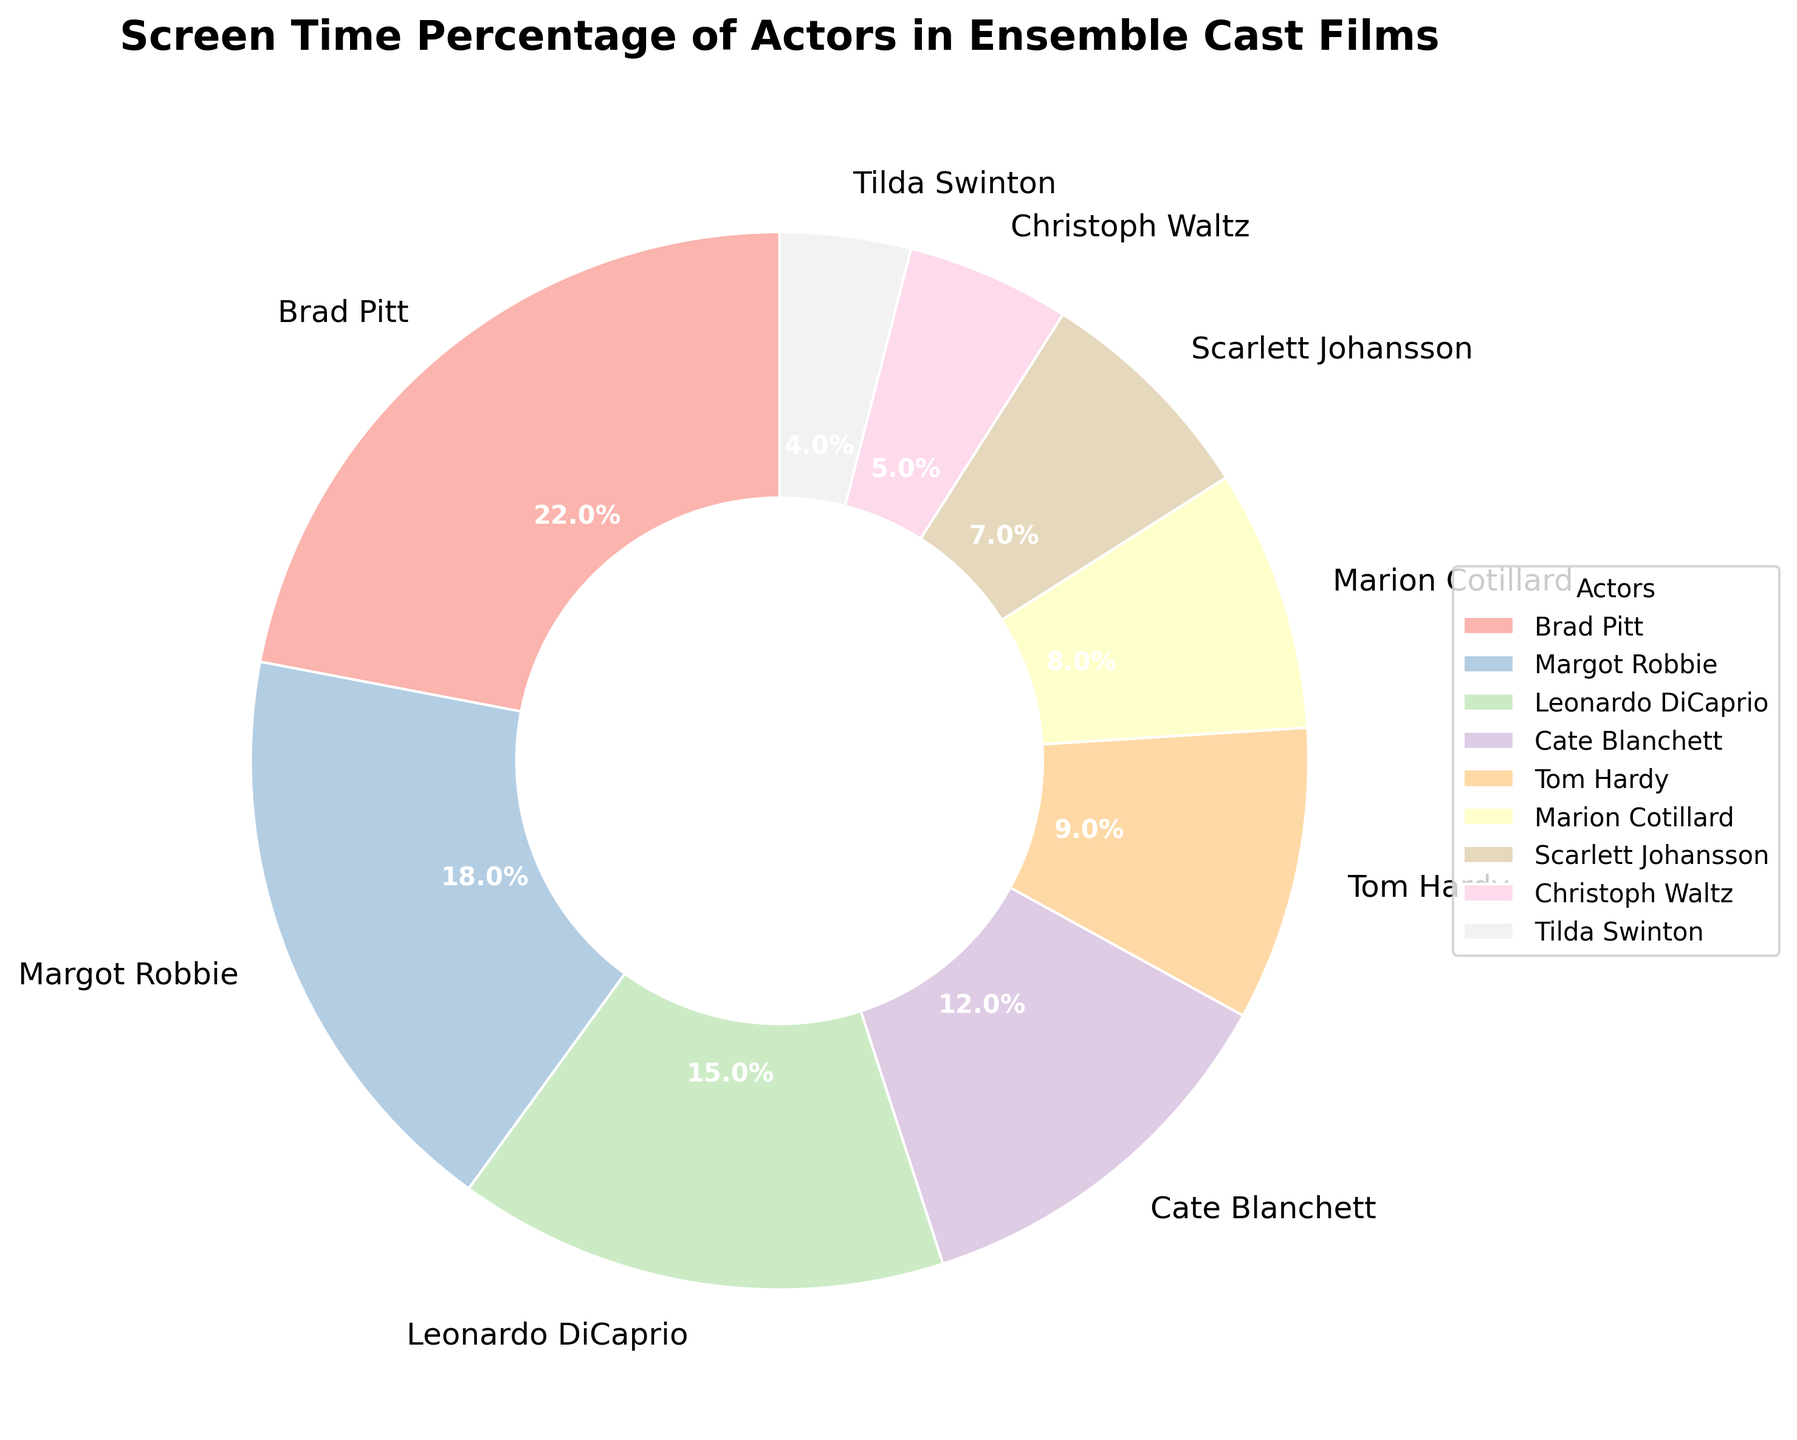Which actor has the highest screen time percentage? To figure this out, look at the largest segment in the pie chart. The segment labeled "Brad Pitt" is the largest one, indicating that Brad Pitt has the highest screen time percentage.
Answer: Brad Pitt Whose screen time percentage is the smallest? Examine the smallest segment in the pie chart. The segment labeled "Tilda Swinton" is the smallest, indicating that Tilda Swinton has the smallest screen time percentage.
Answer: Tilda Swinton What is the combined screen time percentage of the top three actors? Add the screen time percentages of Brad Pitt (22%), Margot Robbie (18%), and Leonardo DiCaprio (15%). 22 + 18 + 15 = 55
Answer: 55% Which actor has more screen time, Leonardo DiCaprio or Tom Hardy? Compare the segments for Leonardo DiCaprio and Tom Hardy. Leonardo DiCaprio's segment (15%) is larger than Tom Hardy's (9%).
Answer: Leonardo DiCaprio What is the difference in screen time percentage between the actor with the highest and the actor with the lowest screen time? Subtract the smallest screen time percentage (Tilda Swinton, 4%) from the largest (Brad Pitt, 22%). 22 - 4 = 18
Answer: 18% How many actors have a screen time percentage greater than 15%? Identify the actors with screen time percentages higher than 15%. These are Brad Pitt (22%) and Margot Robbie (18%). Only 2 actors meet this criteria.
Answer: 2 Are there more actors with a screen time percentage less than 10% or more? Count the actors with screen times less than 10% (Tom Hardy, Marion Cotillard, Scarlett Johansson, Christoph Waltz, Tilda Swinton) which equals 5 actors, and those with more than 10% (Brad Pitt, Margot Robbie, Leonardo DiCaprio, Cate Blanchett) which equals 4 actors. There are more actors with less than 10%.
Answer: less than 10% What's the average screen time percentage of the actors? Sum all the percentages (22 + 18 + 15 + 12 + 9 + 8 + 7 + 5 + 4 = 100) and divide by the number of actors (9). 100 / 9 ≈ 11.1
Answer: 11.1% Is there an actor whose screen time percentage is exactly half of another actor's percentage? Check each actor's screen time to find one that is double another's. Brad Pitt (22%) is double of Cate Blanchett (11%). As no other actor has this relationship, the answer is no.
Answer: No Which two actors have a combined screen time percentage closest to 20%? Add pairs of percentages and compare to 20%. The closest pair is Marion Cotillard (8%) and Scarlett Johansson (7%) whose combined percentage is 15%, which is the closest to 20% without exceeding it.
Answer: Marion Cotillard and Scarlett Johansson 